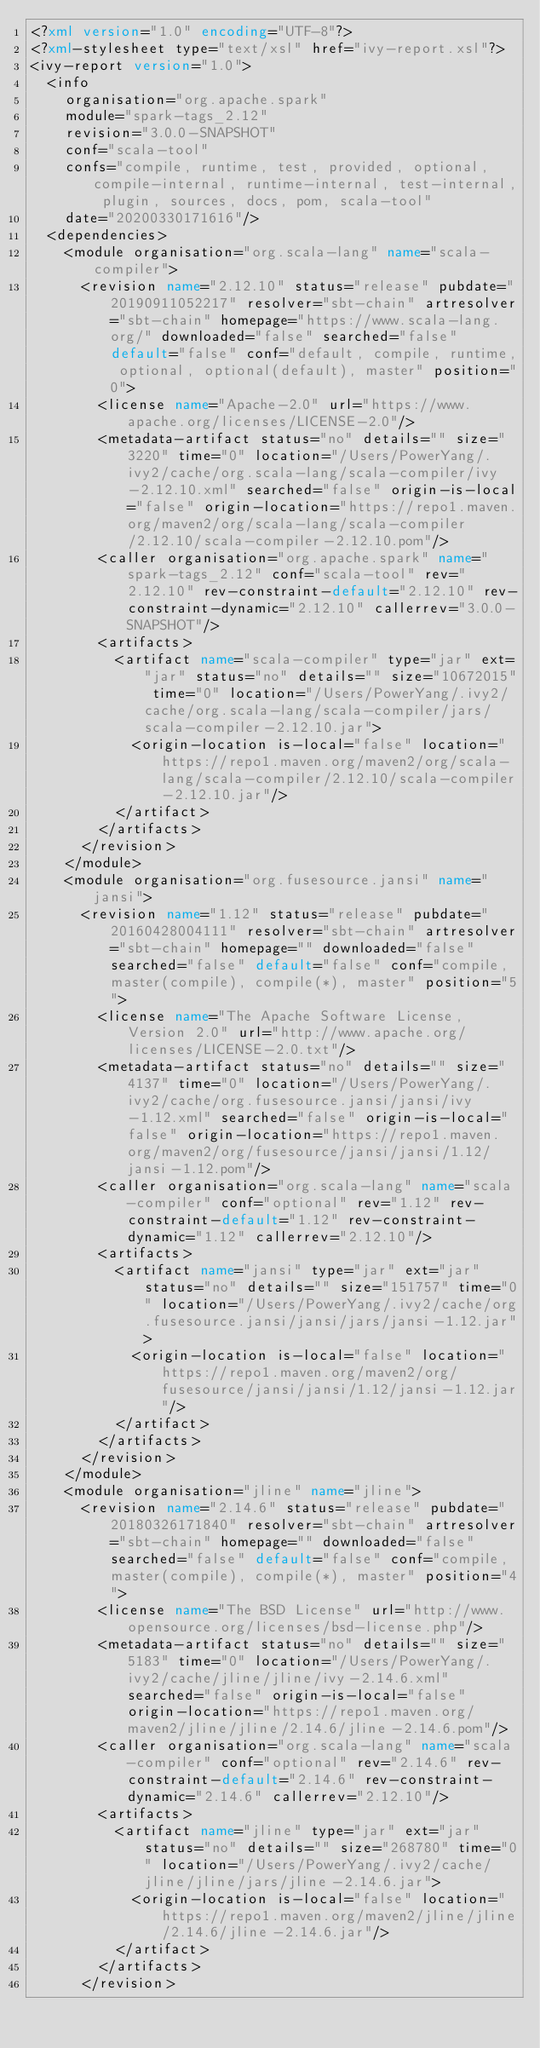<code> <loc_0><loc_0><loc_500><loc_500><_XML_><?xml version="1.0" encoding="UTF-8"?>
<?xml-stylesheet type="text/xsl" href="ivy-report.xsl"?>
<ivy-report version="1.0">
	<info
		organisation="org.apache.spark"
		module="spark-tags_2.12"
		revision="3.0.0-SNAPSHOT"
		conf="scala-tool"
		confs="compile, runtime, test, provided, optional, compile-internal, runtime-internal, test-internal, plugin, sources, docs, pom, scala-tool"
		date="20200330171616"/>
	<dependencies>
		<module organisation="org.scala-lang" name="scala-compiler">
			<revision name="2.12.10" status="release" pubdate="20190911052217" resolver="sbt-chain" artresolver="sbt-chain" homepage="https://www.scala-lang.org/" downloaded="false" searched="false" default="false" conf="default, compile, runtime, optional, optional(default), master" position="0">
				<license name="Apache-2.0" url="https://www.apache.org/licenses/LICENSE-2.0"/>
				<metadata-artifact status="no" details="" size="3220" time="0" location="/Users/PowerYang/.ivy2/cache/org.scala-lang/scala-compiler/ivy-2.12.10.xml" searched="false" origin-is-local="false" origin-location="https://repo1.maven.org/maven2/org/scala-lang/scala-compiler/2.12.10/scala-compiler-2.12.10.pom"/>
				<caller organisation="org.apache.spark" name="spark-tags_2.12" conf="scala-tool" rev="2.12.10" rev-constraint-default="2.12.10" rev-constraint-dynamic="2.12.10" callerrev="3.0.0-SNAPSHOT"/>
				<artifacts>
					<artifact name="scala-compiler" type="jar" ext="jar" status="no" details="" size="10672015" time="0" location="/Users/PowerYang/.ivy2/cache/org.scala-lang/scala-compiler/jars/scala-compiler-2.12.10.jar">
						<origin-location is-local="false" location="https://repo1.maven.org/maven2/org/scala-lang/scala-compiler/2.12.10/scala-compiler-2.12.10.jar"/>
					</artifact>
				</artifacts>
			</revision>
		</module>
		<module organisation="org.fusesource.jansi" name="jansi">
			<revision name="1.12" status="release" pubdate="20160428004111" resolver="sbt-chain" artresolver="sbt-chain" homepage="" downloaded="false" searched="false" default="false" conf="compile, master(compile), compile(*), master" position="5">
				<license name="The Apache Software License, Version 2.0" url="http://www.apache.org/licenses/LICENSE-2.0.txt"/>
				<metadata-artifact status="no" details="" size="4137" time="0" location="/Users/PowerYang/.ivy2/cache/org.fusesource.jansi/jansi/ivy-1.12.xml" searched="false" origin-is-local="false" origin-location="https://repo1.maven.org/maven2/org/fusesource/jansi/jansi/1.12/jansi-1.12.pom"/>
				<caller organisation="org.scala-lang" name="scala-compiler" conf="optional" rev="1.12" rev-constraint-default="1.12" rev-constraint-dynamic="1.12" callerrev="2.12.10"/>
				<artifacts>
					<artifact name="jansi" type="jar" ext="jar" status="no" details="" size="151757" time="0" location="/Users/PowerYang/.ivy2/cache/org.fusesource.jansi/jansi/jars/jansi-1.12.jar">
						<origin-location is-local="false" location="https://repo1.maven.org/maven2/org/fusesource/jansi/jansi/1.12/jansi-1.12.jar"/>
					</artifact>
				</artifacts>
			</revision>
		</module>
		<module organisation="jline" name="jline">
			<revision name="2.14.6" status="release" pubdate="20180326171840" resolver="sbt-chain" artresolver="sbt-chain" homepage="" downloaded="false" searched="false" default="false" conf="compile, master(compile), compile(*), master" position="4">
				<license name="The BSD License" url="http://www.opensource.org/licenses/bsd-license.php"/>
				<metadata-artifact status="no" details="" size="5183" time="0" location="/Users/PowerYang/.ivy2/cache/jline/jline/ivy-2.14.6.xml" searched="false" origin-is-local="false" origin-location="https://repo1.maven.org/maven2/jline/jline/2.14.6/jline-2.14.6.pom"/>
				<caller organisation="org.scala-lang" name="scala-compiler" conf="optional" rev="2.14.6" rev-constraint-default="2.14.6" rev-constraint-dynamic="2.14.6" callerrev="2.12.10"/>
				<artifacts>
					<artifact name="jline" type="jar" ext="jar" status="no" details="" size="268780" time="0" location="/Users/PowerYang/.ivy2/cache/jline/jline/jars/jline-2.14.6.jar">
						<origin-location is-local="false" location="https://repo1.maven.org/maven2/jline/jline/2.14.6/jline-2.14.6.jar"/>
					</artifact>
				</artifacts>
			</revision></code> 